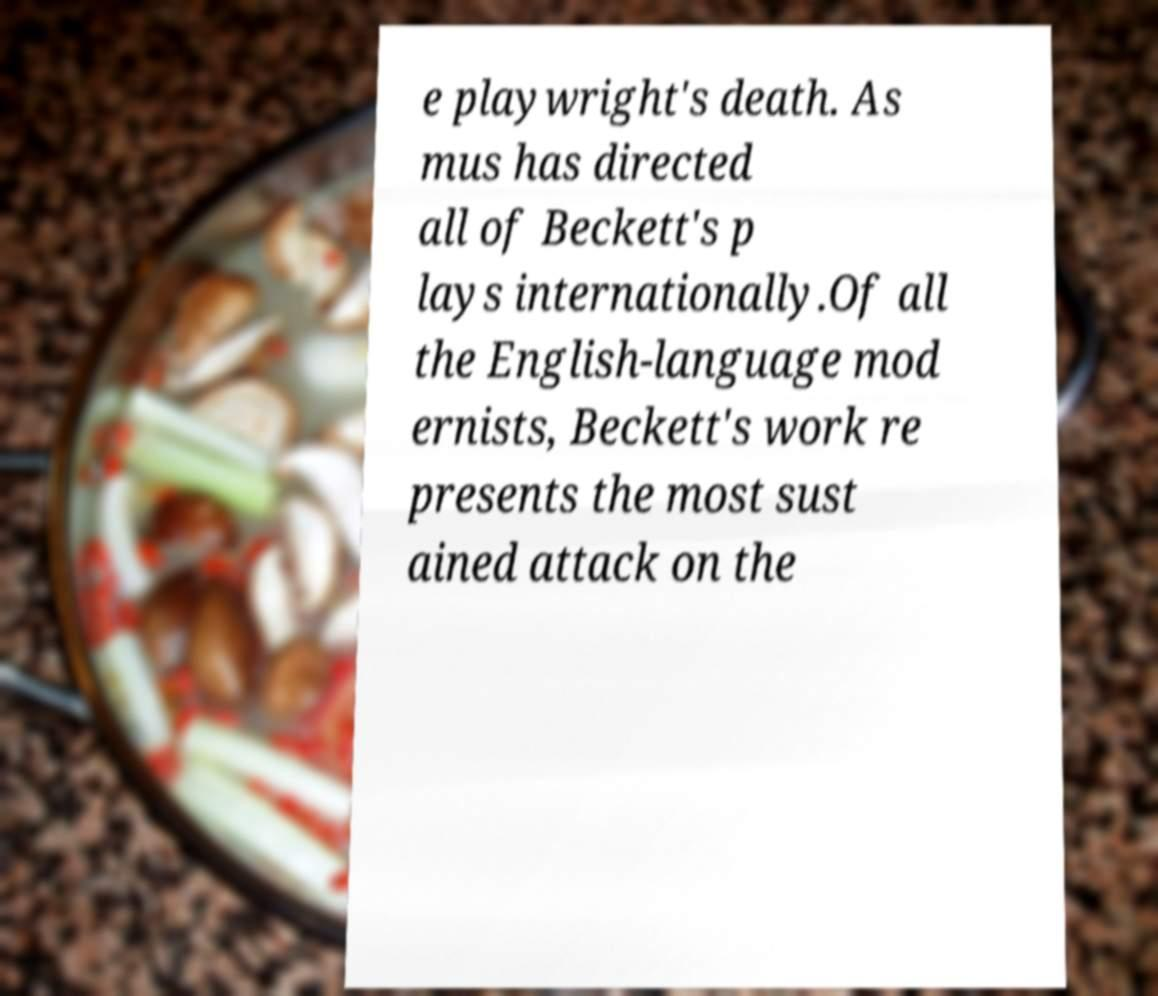Please read and relay the text visible in this image. What does it say? e playwright's death. As mus has directed all of Beckett's p lays internationally.Of all the English-language mod ernists, Beckett's work re presents the most sust ained attack on the 